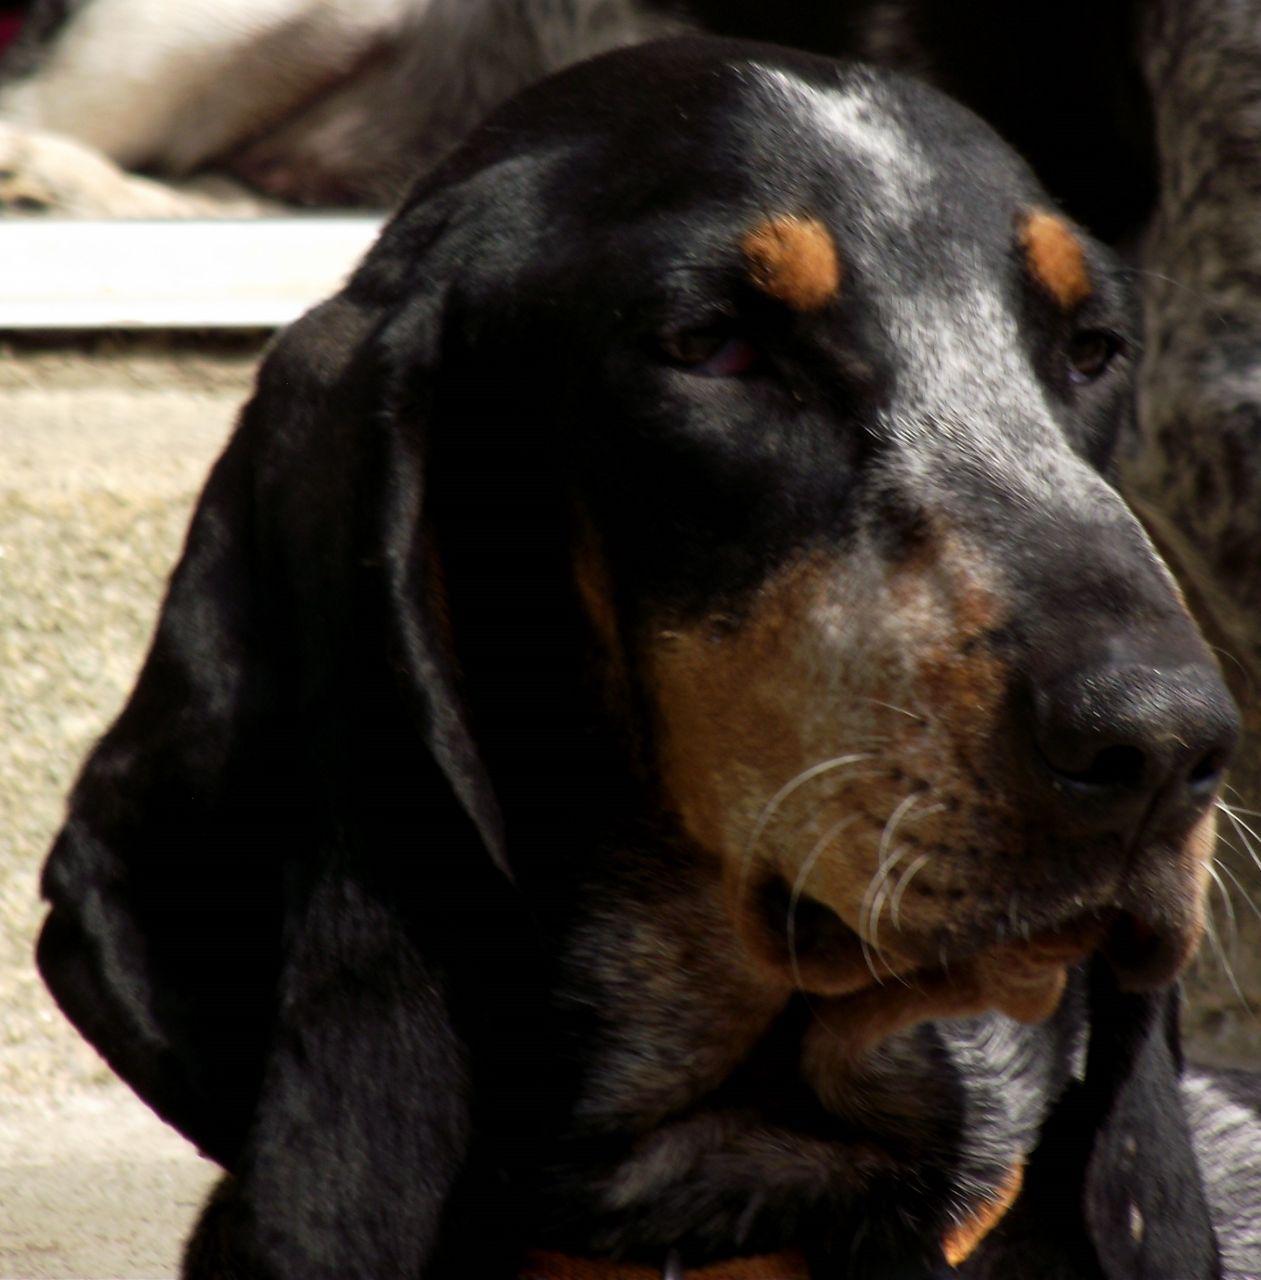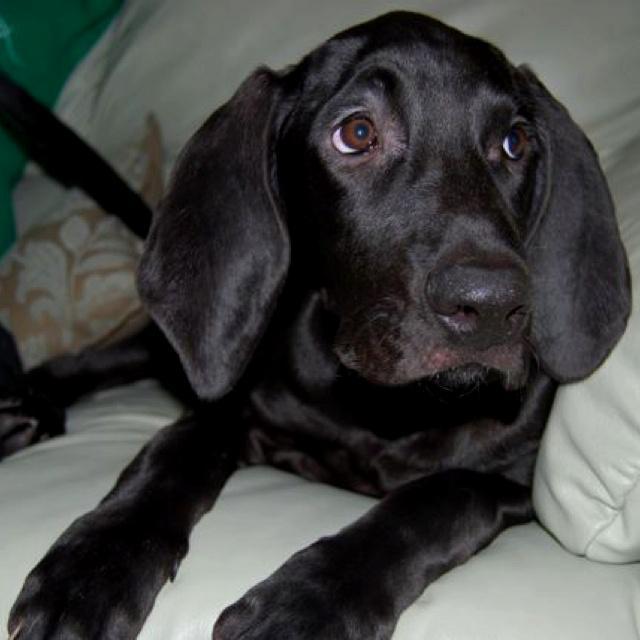The first image is the image on the left, the second image is the image on the right. Examine the images to the left and right. Is the description "There is a black dog in the center of both images." accurate? Answer yes or no. Yes. The first image is the image on the left, the second image is the image on the right. Given the left and right images, does the statement "One of the dogs is sitting on or lying next to a pillow." hold true? Answer yes or no. Yes. 